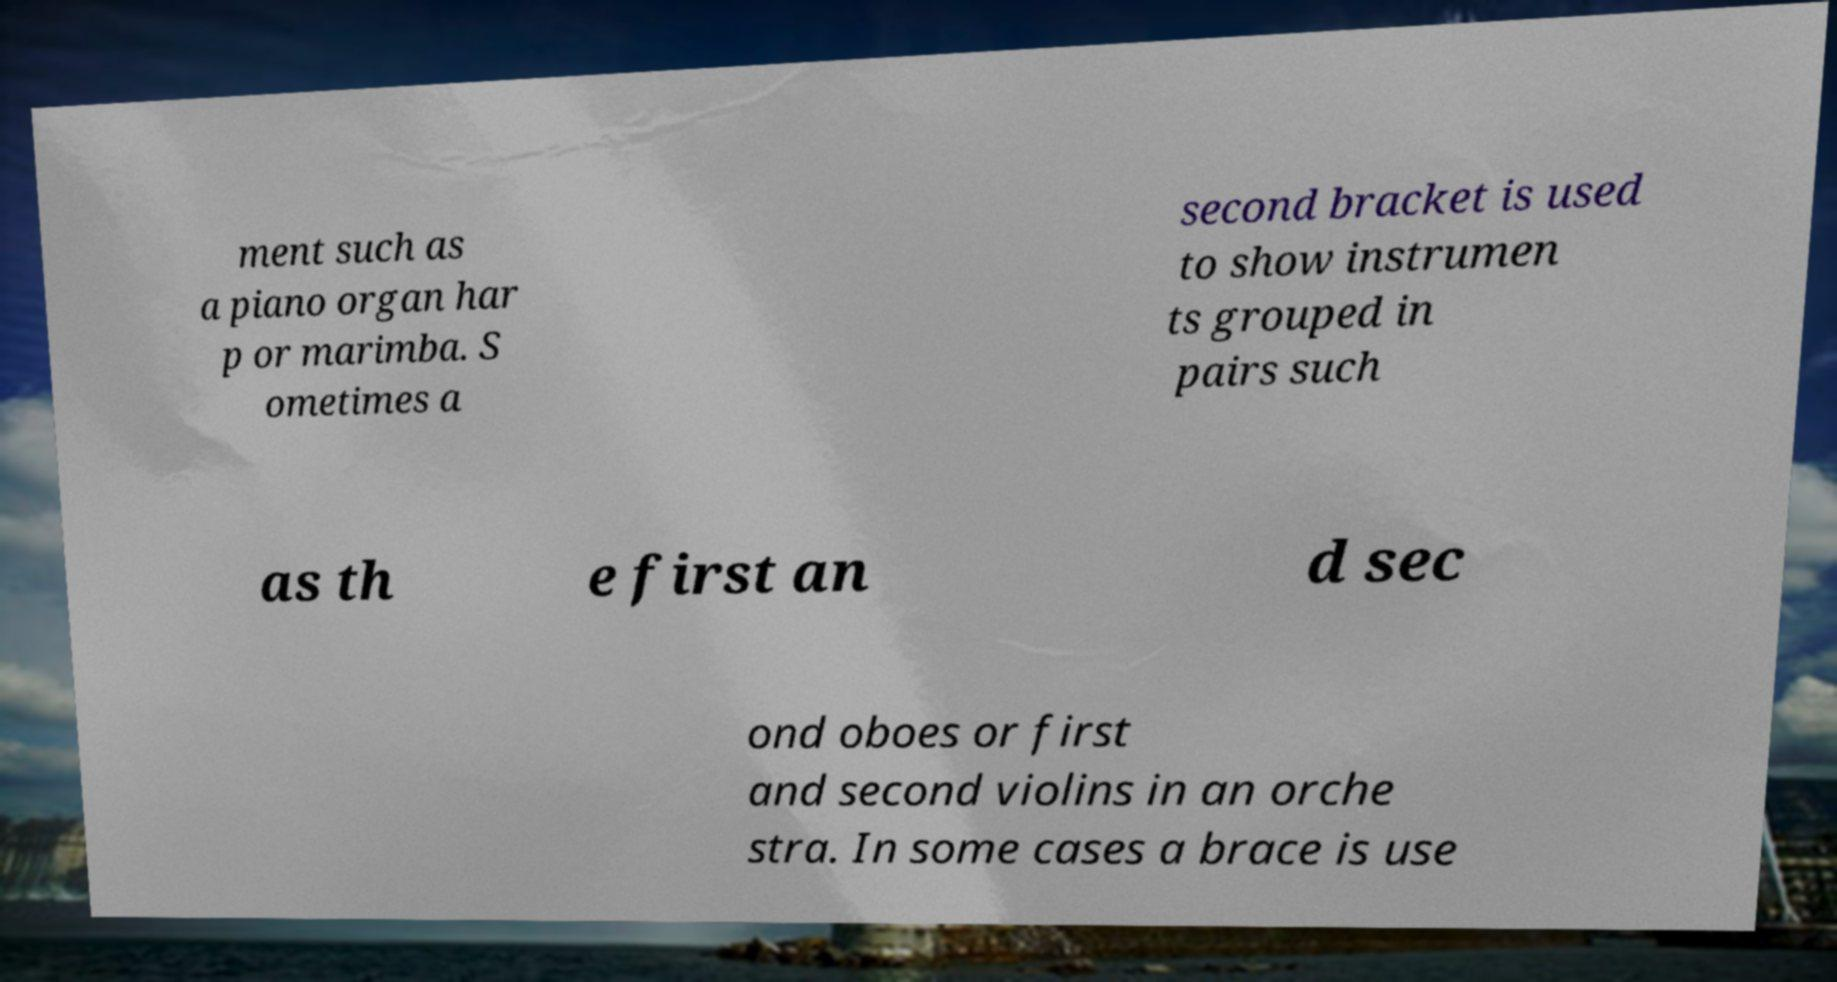There's text embedded in this image that I need extracted. Can you transcribe it verbatim? ment such as a piano organ har p or marimba. S ometimes a second bracket is used to show instrumen ts grouped in pairs such as th e first an d sec ond oboes or first and second violins in an orche stra. In some cases a brace is use 